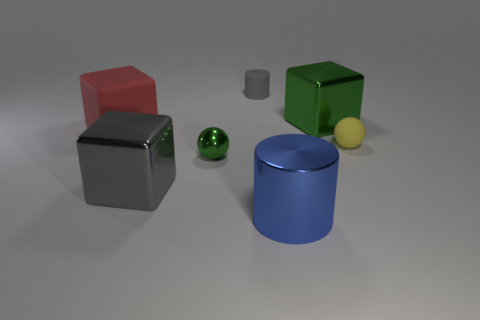Is there anything else that has the same size as the red block?
Your answer should be very brief. Yes. Does the small metal sphere have the same color as the large rubber object?
Your answer should be compact. No. The metallic object that is the same color as the small cylinder is what shape?
Keep it short and to the point. Cube. What number of gray objects are the same shape as the blue metallic thing?
Provide a succinct answer. 1. What size is the sphere that is the same material as the large red thing?
Provide a short and direct response. Small. Is the size of the blue metal thing the same as the gray shiny block?
Offer a terse response. Yes. Are there any big gray spheres?
Your answer should be compact. No. There is a thing that is the same color as the tiny matte cylinder; what is its size?
Your answer should be very brief. Large. There is a green metal thing behind the tiny object that is to the right of the green thing that is behind the red thing; how big is it?
Ensure brevity in your answer.  Large. What number of large cyan balls are made of the same material as the large green object?
Provide a short and direct response. 0. 